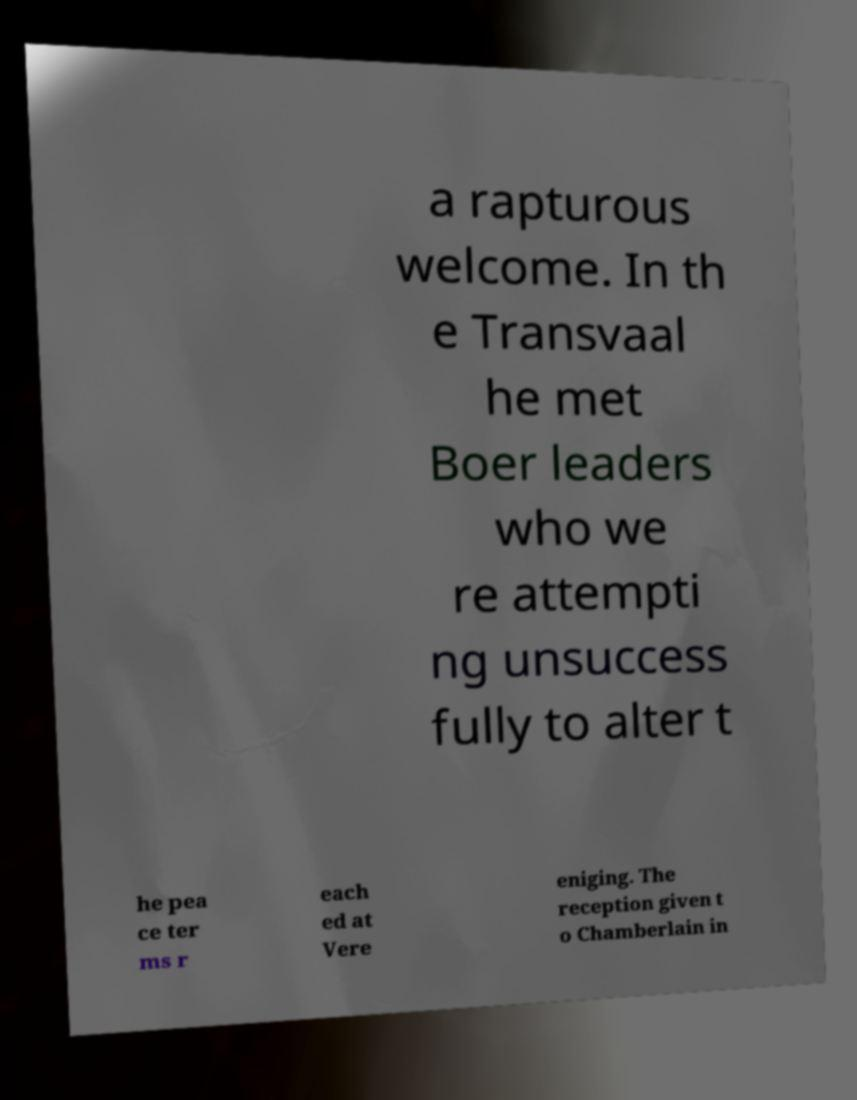Could you assist in decoding the text presented in this image and type it out clearly? a rapturous welcome. In th e Transvaal he met Boer leaders who we re attempti ng unsuccess fully to alter t he pea ce ter ms r each ed at Vere eniging. The reception given t o Chamberlain in 